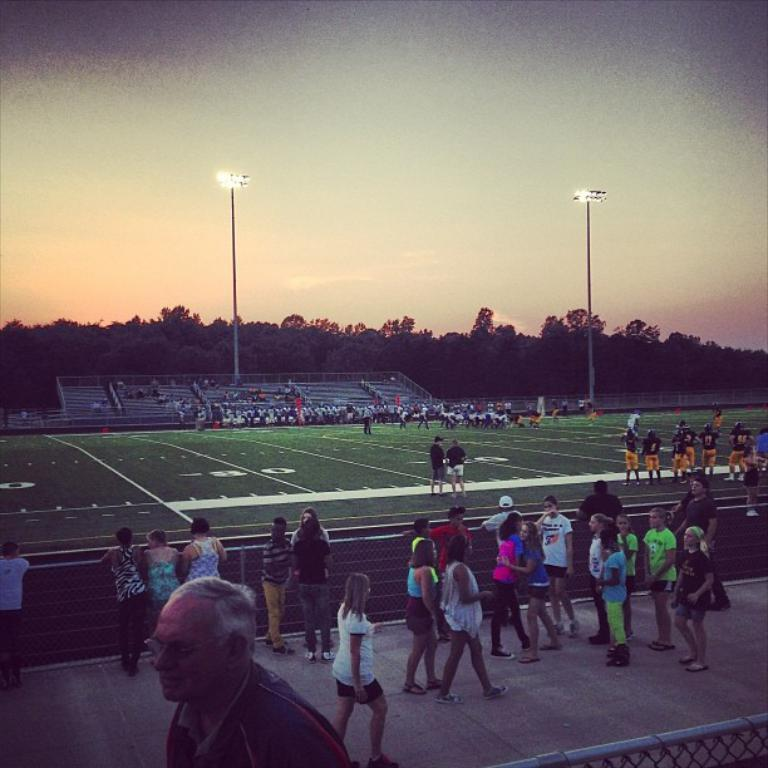Who is the main subject in the image? There is an old man in the image. What are the girls in the image doing? The girls are walking in the image. On which side of the image are the girls located? The girls are on the right side of the image. What is the surface that the old man and the girls are standing on? There is a ground in the middle of the image. What can be seen illuminating the scene in the image? There are lights in the image. What is visible at the top of the image? The sky is visible at the top of the image. What type of skin is visible on the mask worn by the old man in the image? There is no mask or mention of skin in the image; the old man is not wearing a mask. What color is the suit worn by the girls in the image? There is no suit visible in the image; the girls are not wearing suits. 